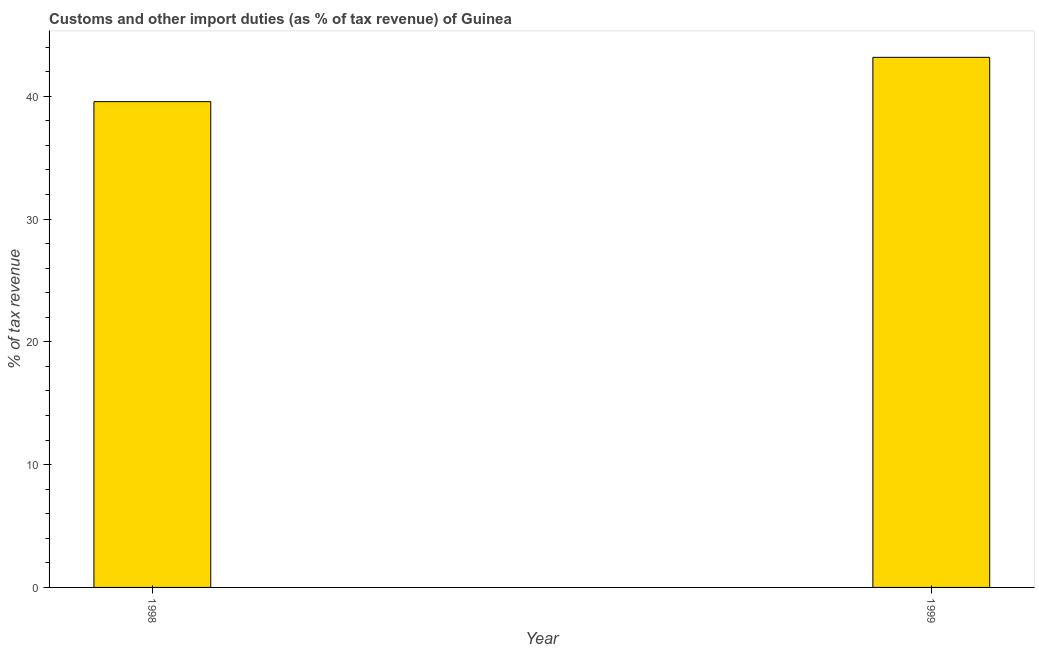Does the graph contain any zero values?
Keep it short and to the point. No. Does the graph contain grids?
Your answer should be very brief. No. What is the title of the graph?
Ensure brevity in your answer.  Customs and other import duties (as % of tax revenue) of Guinea. What is the label or title of the X-axis?
Keep it short and to the point. Year. What is the label or title of the Y-axis?
Give a very brief answer. % of tax revenue. What is the customs and other import duties in 1998?
Provide a short and direct response. 39.57. Across all years, what is the maximum customs and other import duties?
Provide a short and direct response. 43.18. Across all years, what is the minimum customs and other import duties?
Make the answer very short. 39.57. In which year was the customs and other import duties maximum?
Offer a very short reply. 1999. In which year was the customs and other import duties minimum?
Your answer should be very brief. 1998. What is the sum of the customs and other import duties?
Make the answer very short. 82.74. What is the difference between the customs and other import duties in 1998 and 1999?
Make the answer very short. -3.61. What is the average customs and other import duties per year?
Make the answer very short. 41.37. What is the median customs and other import duties?
Offer a very short reply. 41.37. In how many years, is the customs and other import duties greater than 18 %?
Your response must be concise. 2. Do a majority of the years between 1999 and 1998 (inclusive) have customs and other import duties greater than 2 %?
Give a very brief answer. No. What is the ratio of the customs and other import duties in 1998 to that in 1999?
Your response must be concise. 0.92. Is the customs and other import duties in 1998 less than that in 1999?
Make the answer very short. Yes. In how many years, is the customs and other import duties greater than the average customs and other import duties taken over all years?
Offer a very short reply. 1. Are all the bars in the graph horizontal?
Give a very brief answer. No. How many years are there in the graph?
Keep it short and to the point. 2. What is the difference between two consecutive major ticks on the Y-axis?
Provide a succinct answer. 10. Are the values on the major ticks of Y-axis written in scientific E-notation?
Ensure brevity in your answer.  No. What is the % of tax revenue of 1998?
Your answer should be compact. 39.57. What is the % of tax revenue in 1999?
Keep it short and to the point. 43.18. What is the difference between the % of tax revenue in 1998 and 1999?
Give a very brief answer. -3.61. What is the ratio of the % of tax revenue in 1998 to that in 1999?
Make the answer very short. 0.92. 